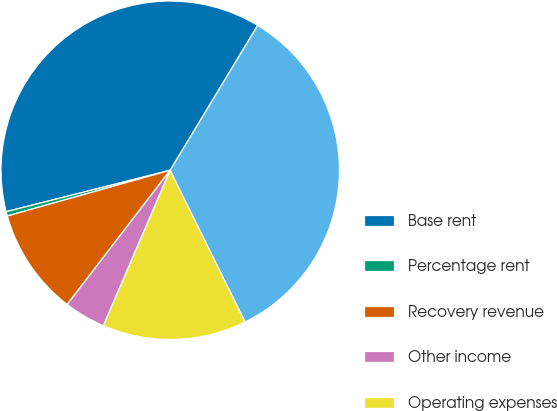Convert chart to OTSL. <chart><loc_0><loc_0><loc_500><loc_500><pie_chart><fcel>Base rent<fcel>Percentage rent<fcel>Recovery revenue<fcel>Other income<fcel>Operating expenses<fcel>Pro rata same property NOI<nl><fcel>37.59%<fcel>0.42%<fcel>10.22%<fcel>3.96%<fcel>13.76%<fcel>34.05%<nl></chart> 